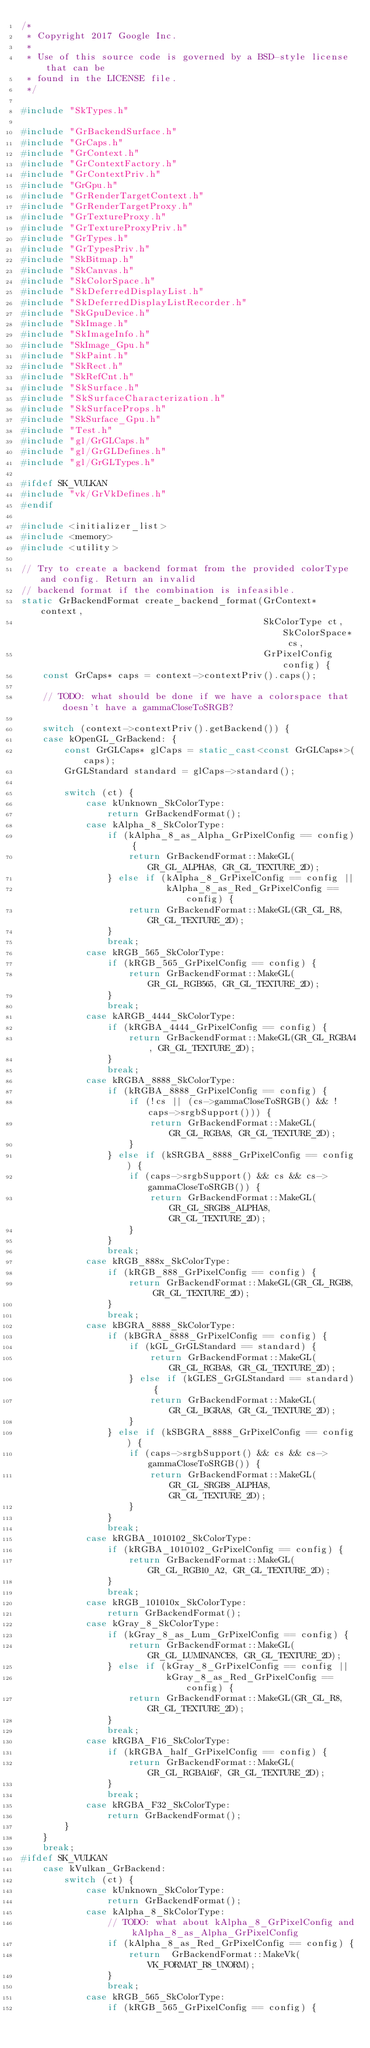Convert code to text. <code><loc_0><loc_0><loc_500><loc_500><_C++_>/*
 * Copyright 2017 Google Inc.
 *
 * Use of this source code is governed by a BSD-style license that can be
 * found in the LICENSE file.
 */

#include "SkTypes.h"

#include "GrBackendSurface.h"
#include "GrCaps.h"
#include "GrContext.h"
#include "GrContextFactory.h"
#include "GrContextPriv.h"
#include "GrGpu.h"
#include "GrRenderTargetContext.h"
#include "GrRenderTargetProxy.h"
#include "GrTextureProxy.h"
#include "GrTextureProxyPriv.h"
#include "GrTypes.h"
#include "GrTypesPriv.h"
#include "SkBitmap.h"
#include "SkCanvas.h"
#include "SkColorSpace.h"
#include "SkDeferredDisplayList.h"
#include "SkDeferredDisplayListRecorder.h"
#include "SkGpuDevice.h"
#include "SkImage.h"
#include "SkImageInfo.h"
#include "SkImage_Gpu.h"
#include "SkPaint.h"
#include "SkRect.h"
#include "SkRefCnt.h"
#include "SkSurface.h"
#include "SkSurfaceCharacterization.h"
#include "SkSurfaceProps.h"
#include "SkSurface_Gpu.h"
#include "Test.h"
#include "gl/GrGLCaps.h"
#include "gl/GrGLDefines.h"
#include "gl/GrGLTypes.h"

#ifdef SK_VULKAN
#include "vk/GrVkDefines.h"
#endif

#include <initializer_list>
#include <memory>
#include <utility>

// Try to create a backend format from the provided colorType and config. Return an invalid
// backend format if the combination is infeasible.
static GrBackendFormat create_backend_format(GrContext* context,
                                             SkColorType ct, SkColorSpace* cs,
                                             GrPixelConfig config) {
    const GrCaps* caps = context->contextPriv().caps();

    // TODO: what should be done if we have a colorspace that doesn't have a gammaCloseToSRGB?

    switch (context->contextPriv().getBackend()) {
    case kOpenGL_GrBackend: {
        const GrGLCaps* glCaps = static_cast<const GrGLCaps*>(caps);
        GrGLStandard standard = glCaps->standard();

        switch (ct) {
            case kUnknown_SkColorType:
                return GrBackendFormat();
            case kAlpha_8_SkColorType:
                if (kAlpha_8_as_Alpha_GrPixelConfig == config) {
                    return GrBackendFormat::MakeGL(GR_GL_ALPHA8, GR_GL_TEXTURE_2D);
                } else if (kAlpha_8_GrPixelConfig == config ||
                           kAlpha_8_as_Red_GrPixelConfig == config) {
                    return GrBackendFormat::MakeGL(GR_GL_R8, GR_GL_TEXTURE_2D);
                }
                break;
            case kRGB_565_SkColorType:
                if (kRGB_565_GrPixelConfig == config) {
                    return GrBackendFormat::MakeGL(GR_GL_RGB565, GR_GL_TEXTURE_2D);
                }
                break;
            case kARGB_4444_SkColorType:
                if (kRGBA_4444_GrPixelConfig == config) {
                    return GrBackendFormat::MakeGL(GR_GL_RGBA4, GR_GL_TEXTURE_2D);
                }
                break;
            case kRGBA_8888_SkColorType:
                if (kRGBA_8888_GrPixelConfig == config) {
                    if (!cs || (cs->gammaCloseToSRGB() && !caps->srgbSupport())) {
                        return GrBackendFormat::MakeGL(GR_GL_RGBA8, GR_GL_TEXTURE_2D);
                    }
                } else if (kSRGBA_8888_GrPixelConfig == config) {
                    if (caps->srgbSupport() && cs && cs->gammaCloseToSRGB()) {
                        return GrBackendFormat::MakeGL(GR_GL_SRGB8_ALPHA8, GR_GL_TEXTURE_2D);
                    }
                }
                break;
            case kRGB_888x_SkColorType:
                if (kRGB_888_GrPixelConfig == config) {
                    return GrBackendFormat::MakeGL(GR_GL_RGB8, GR_GL_TEXTURE_2D);
                }
                break;
            case kBGRA_8888_SkColorType:
                if (kBGRA_8888_GrPixelConfig == config) {
                    if (kGL_GrGLStandard == standard) {
                        return GrBackendFormat::MakeGL(GR_GL_RGBA8, GR_GL_TEXTURE_2D);
                    } else if (kGLES_GrGLStandard == standard) {
                        return GrBackendFormat::MakeGL(GR_GL_BGRA8, GR_GL_TEXTURE_2D);
                    }
                } else if (kSBGRA_8888_GrPixelConfig == config) {
                    if (caps->srgbSupport() && cs && cs->gammaCloseToSRGB()) {
                        return GrBackendFormat::MakeGL(GR_GL_SRGB8_ALPHA8, GR_GL_TEXTURE_2D);
                    }
                }
                break;
            case kRGBA_1010102_SkColorType:
                if (kRGBA_1010102_GrPixelConfig == config) {
                    return GrBackendFormat::MakeGL(GR_GL_RGB10_A2, GR_GL_TEXTURE_2D);
                }
                break;
            case kRGB_101010x_SkColorType:
                return GrBackendFormat();
            case kGray_8_SkColorType:
                if (kGray_8_as_Lum_GrPixelConfig == config) {
                    return GrBackendFormat::MakeGL(GR_GL_LUMINANCE8, GR_GL_TEXTURE_2D);
                } else if (kGray_8_GrPixelConfig == config ||
                           kGray_8_as_Red_GrPixelConfig == config) {
                    return GrBackendFormat::MakeGL(GR_GL_R8, GR_GL_TEXTURE_2D);
                }
                break;
            case kRGBA_F16_SkColorType:
                if (kRGBA_half_GrPixelConfig == config) {
                    return GrBackendFormat::MakeGL(GR_GL_RGBA16F, GR_GL_TEXTURE_2D);
                }
                break;
            case kRGBA_F32_SkColorType:
                return GrBackendFormat();
        }
    }
    break;
#ifdef SK_VULKAN
    case kVulkan_GrBackend:
        switch (ct) {
            case kUnknown_SkColorType:
                return GrBackendFormat();
            case kAlpha_8_SkColorType:
                // TODO: what about kAlpha_8_GrPixelConfig and kAlpha_8_as_Alpha_GrPixelConfig
                if (kAlpha_8_as_Red_GrPixelConfig == config) {
                    return  GrBackendFormat::MakeVk(VK_FORMAT_R8_UNORM);
                }
                break;
            case kRGB_565_SkColorType:
                if (kRGB_565_GrPixelConfig == config) {</code> 